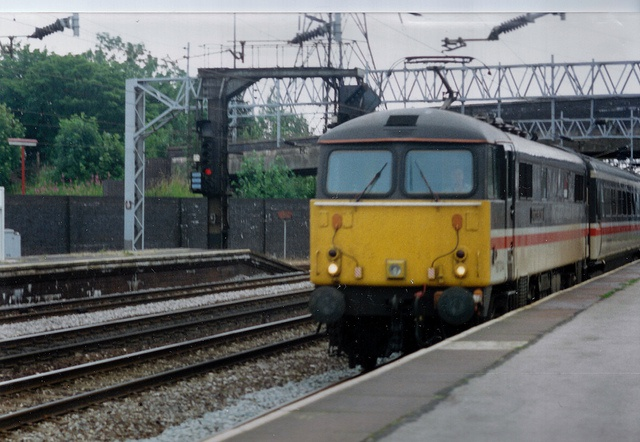Describe the objects in this image and their specific colors. I can see train in lightgray, black, gray, and olive tones and traffic light in lightgray, black, gray, and blue tones in this image. 